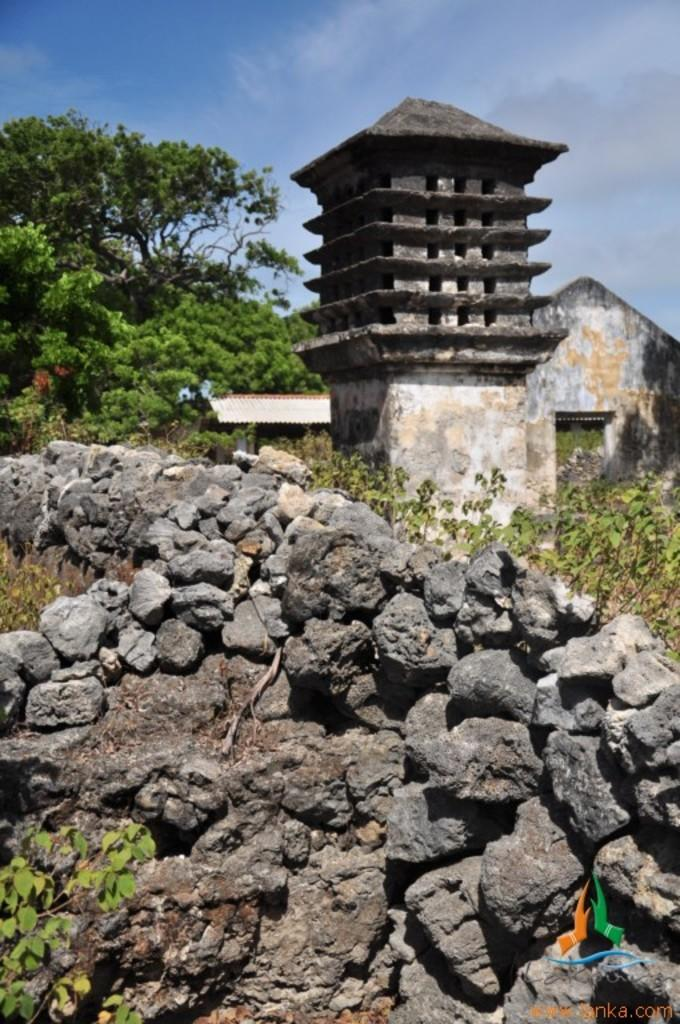What type of natural elements can be seen in the image? There are trees and rocks in the image. What type of man-made structures are present in the image? There are sheds and an architecture in the image. What type of vegetation is present in the image? There are plants in the image. What is visible in the sky at the top of the image? There are clouds in the sky at the top of the image. What type of text can be seen in the image? There is some text in the image. What type of symbol is present in the image? There is a logo in the image. What type of feeling can be seen in the image? Feelings are not visible in the image; it is a still picture. What type of magic is present in the image? There is no magic present in the image; it is a realistic scene. What type of cobweb can be seen in the image? There is no cobweb present in the image. 